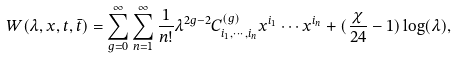Convert formula to latex. <formula><loc_0><loc_0><loc_500><loc_500>W ( \lambda , x , t , \bar { t } ) = \sum _ { g = 0 } ^ { \infty } \sum _ { n = 1 } ^ { \infty } \frac { 1 } { n ! } \lambda ^ { 2 g - 2 } C ^ { ( g ) } _ { i _ { 1 } , \cdots , i _ { n } } x ^ { i _ { 1 } } \cdots x ^ { i _ { n } } + ( \frac { \chi } { 2 4 } - 1 ) \log ( \lambda ) ,</formula> 